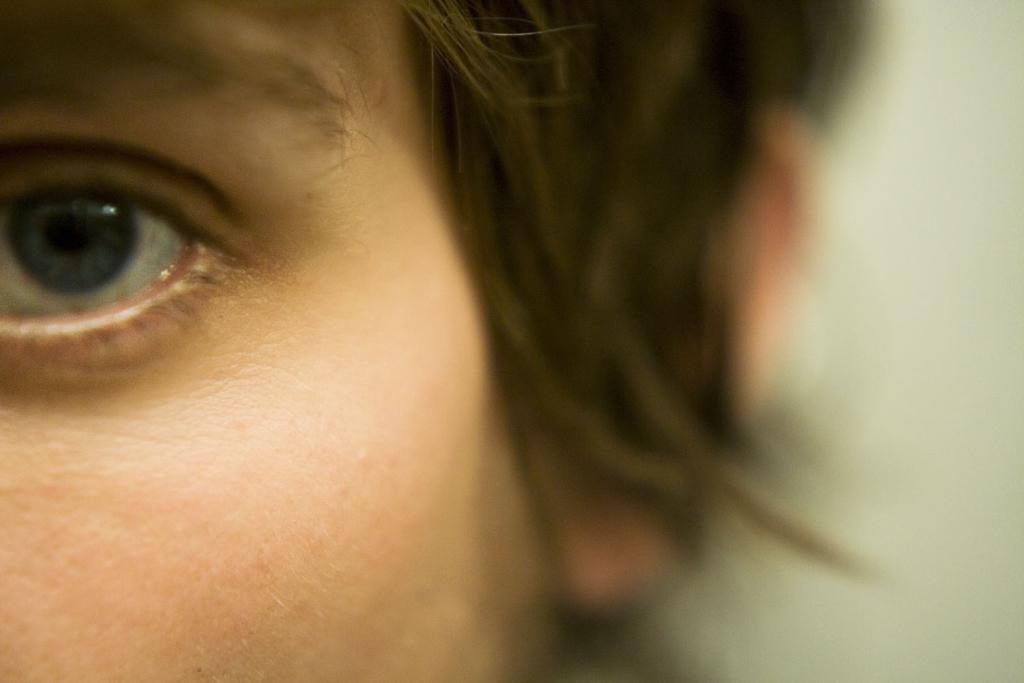What is depicted on the left side of the image? There is a face of a person on the left side of the image. What color can be seen on the right side of the image? There is white color on the right side of the image. Can you see the person's trousers in the image? There is no mention of trousers in the provided facts, and the image only shows a face of a person on the left side and white color on the right side. Is there a bike visible in the image? There is no mention of a bike in the provided facts, and the image only shows a face of a person on the left side and white color on the right side. 